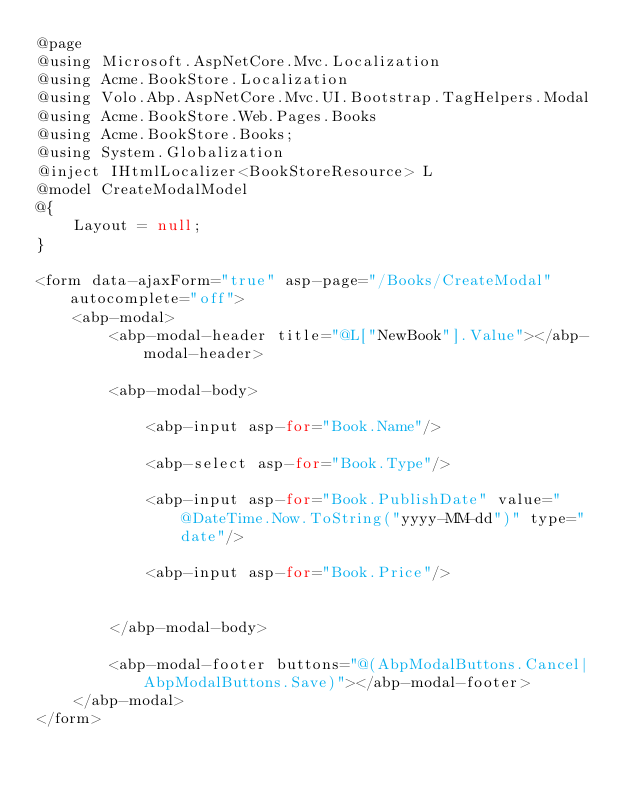<code> <loc_0><loc_0><loc_500><loc_500><_C#_>@page
@using Microsoft.AspNetCore.Mvc.Localization
@using Acme.BookStore.Localization
@using Volo.Abp.AspNetCore.Mvc.UI.Bootstrap.TagHelpers.Modal
@using Acme.BookStore.Web.Pages.Books
@using Acme.BookStore.Books;
@using System.Globalization
@inject IHtmlLocalizer<BookStoreResource> L
@model CreateModalModel
@{
    Layout = null;
}

<form data-ajaxForm="true" asp-page="/Books/CreateModal" autocomplete="off">
    <abp-modal>
        <abp-modal-header title="@L["NewBook"].Value"></abp-modal-header>

        <abp-modal-body>
            
            <abp-input asp-for="Book.Name"/>

            <abp-select asp-for="Book.Type"/>

            <abp-input asp-for="Book.PublishDate" value="@DateTime.Now.ToString("yyyy-MM-dd")" type="date"/>

            <abp-input asp-for="Book.Price"/>

            
        </abp-modal-body>

        <abp-modal-footer buttons="@(AbpModalButtons.Cancel|AbpModalButtons.Save)"></abp-modal-footer>
    </abp-modal>
</form></code> 